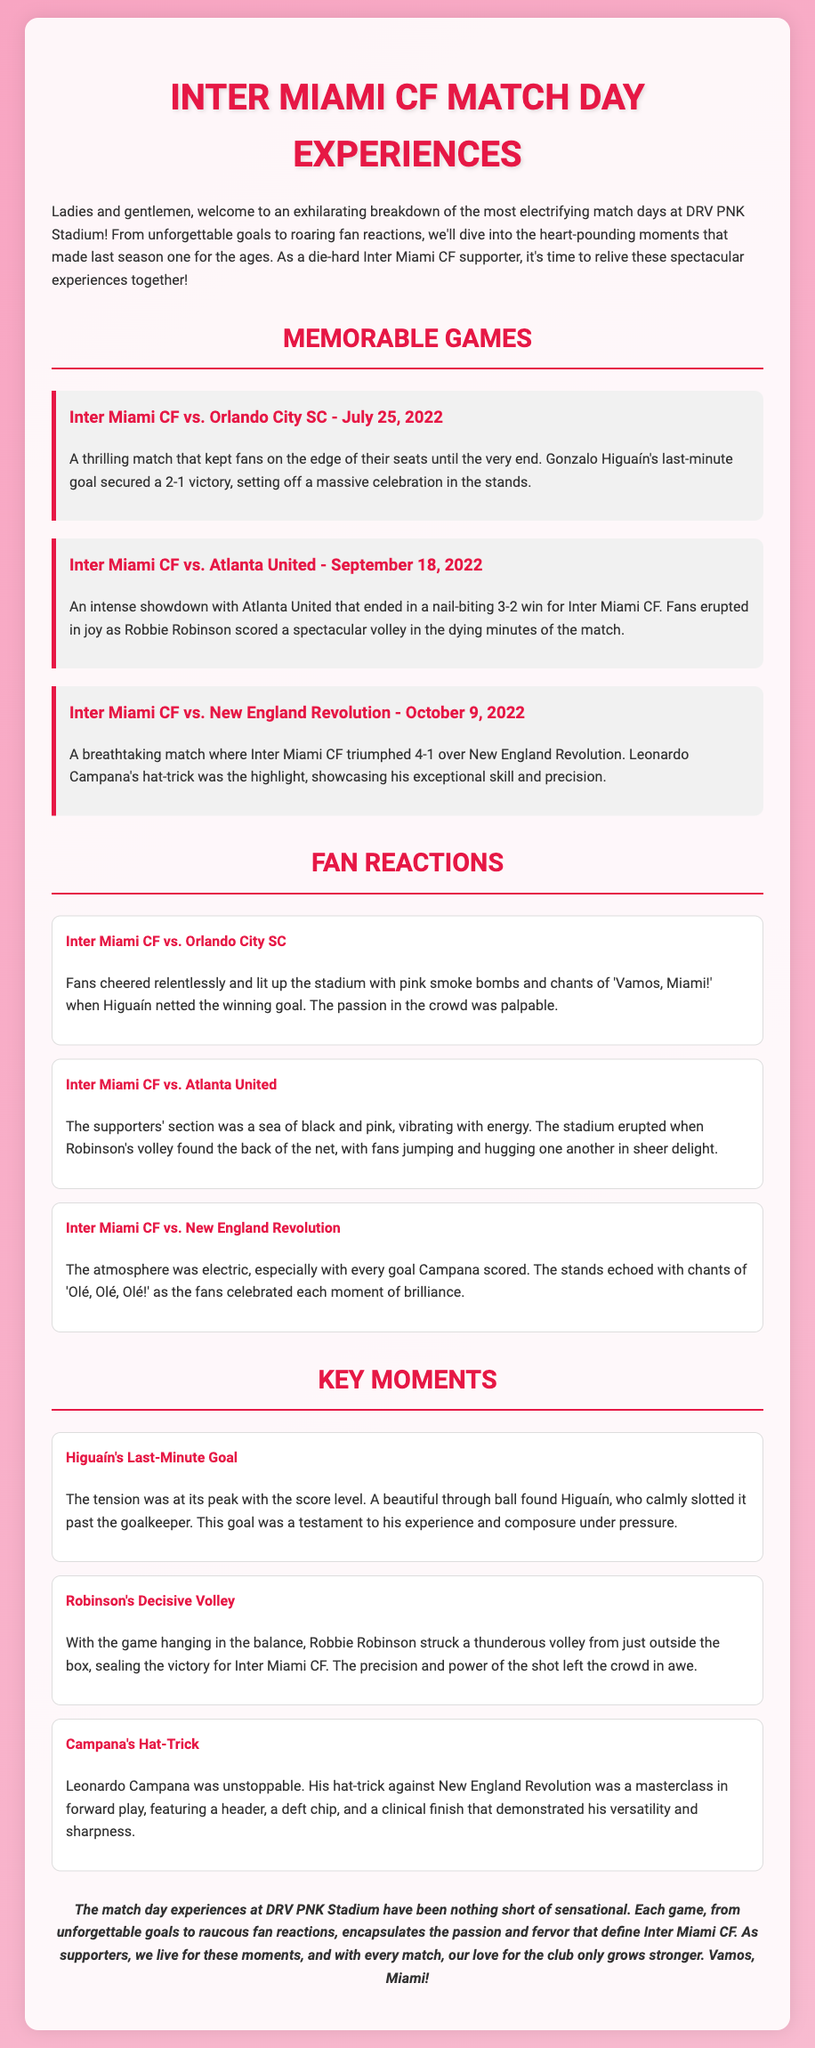what was the date of Inter Miami's match against Orlando City SC? The match against Orlando City SC took place on July 25, 2022.
Answer: July 25, 2022 who scored the last-minute goal against Orlando City SC? Gonzalo Higuaín scored the last-minute goal that secured victory in the match.
Answer: Gonzalo Higuaín what was the final score of the match against Atlanta United? Inter Miami CF triumphed with a score of 3-2 against Atlanta United.
Answer: 3-2 how many goals did Leonardo Campana score in the match against New England Revolution? Leonardo Campana scored three goals in the match, which is referred to as a hat-trick.
Answer: three what chant did fans sing during Campana's performance? The fans echoed chants of 'Olé, Olé, Olé!' during Campana's performance.
Answer: Olé, Olé, Olé which player scored a spectacular volley against Atlanta United? Robbie Robinson scored a spectacular volley in the dying minutes of the match against Atlanta United.
Answer: Robbie Robinson which phrase captures the essence of the fan experience at DRV PNK Stadium? The fan experience is characterized by cheers, celebrations, and moments of pure joy.
Answer: cheers, celebrations what was the highlight of the match against New England Revolution? The highlight of the match was Leonardo Campana's hat-trick.
Answer: Leonardo Campana's hat-trick what overarching theme is presented in the conclusion of the document? The conclusion emphasizes the excitement and passion of match days at DRV PNK Stadium.
Answer: excitement and passion 